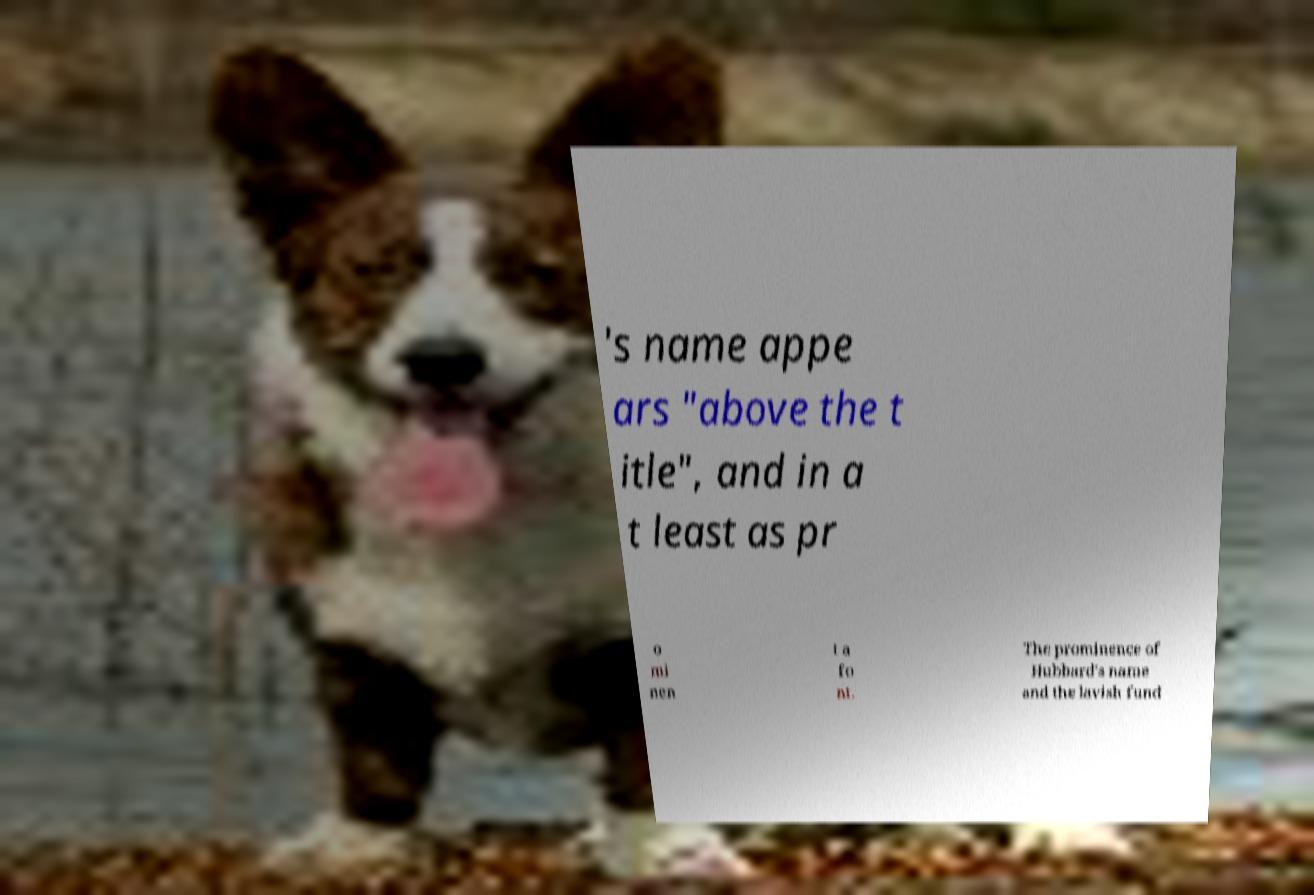For documentation purposes, I need the text within this image transcribed. Could you provide that? 's name appe ars "above the t itle", and in a t least as pr o mi nen t a fo nt. The prominence of Hubbard's name and the lavish fund 